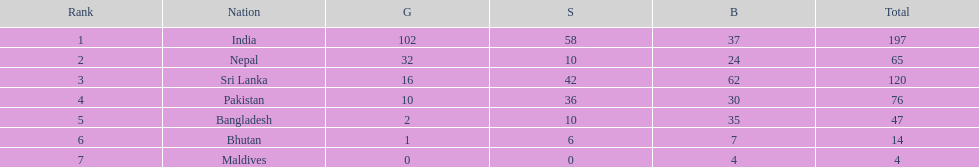How many gold medals did india win? 102. 